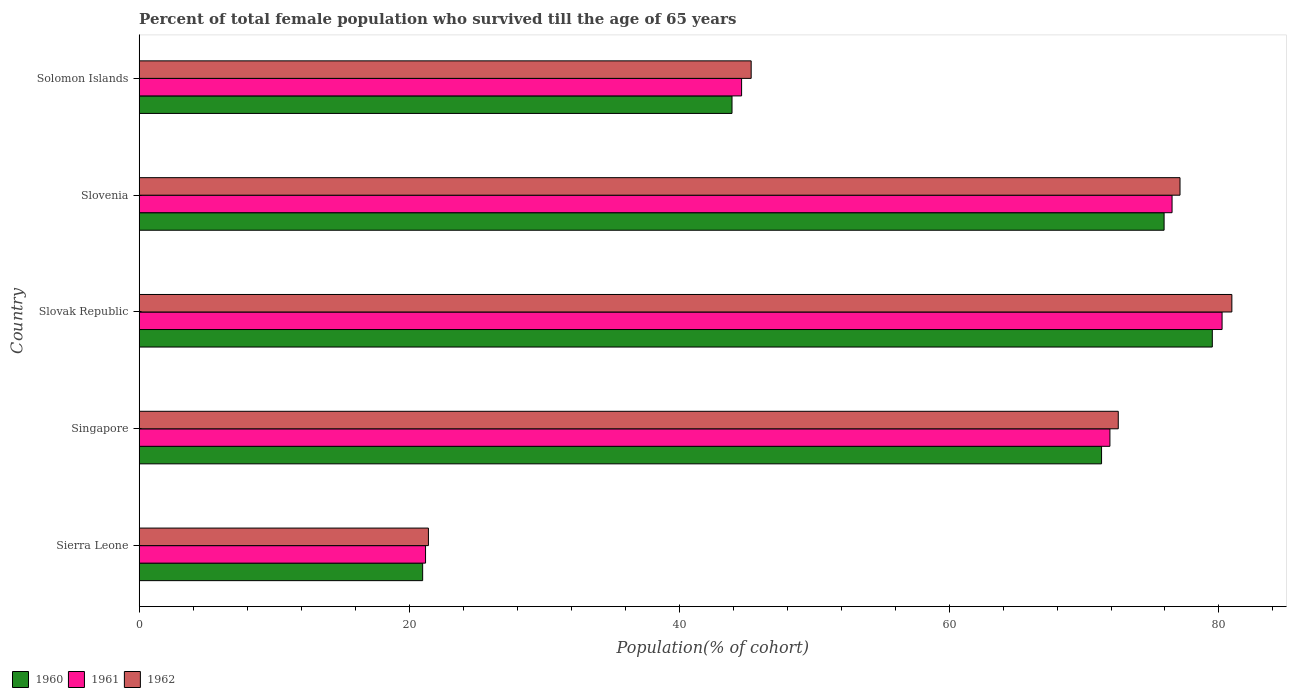How many groups of bars are there?
Your answer should be compact. 5. How many bars are there on the 5th tick from the top?
Offer a terse response. 3. How many bars are there on the 4th tick from the bottom?
Provide a succinct answer. 3. What is the label of the 1st group of bars from the top?
Give a very brief answer. Solomon Islands. In how many cases, is the number of bars for a given country not equal to the number of legend labels?
Your answer should be compact. 0. What is the percentage of total female population who survived till the age of 65 years in 1962 in Slovenia?
Offer a terse response. 77.11. Across all countries, what is the maximum percentage of total female population who survived till the age of 65 years in 1961?
Give a very brief answer. 80.23. Across all countries, what is the minimum percentage of total female population who survived till the age of 65 years in 1960?
Give a very brief answer. 21. In which country was the percentage of total female population who survived till the age of 65 years in 1960 maximum?
Your response must be concise. Slovak Republic. In which country was the percentage of total female population who survived till the age of 65 years in 1961 minimum?
Provide a short and direct response. Sierra Leone. What is the total percentage of total female population who survived till the age of 65 years in 1960 in the graph?
Your answer should be compact. 291.67. What is the difference between the percentage of total female population who survived till the age of 65 years in 1960 in Slovak Republic and that in Solomon Islands?
Your answer should be very brief. 35.58. What is the difference between the percentage of total female population who survived till the age of 65 years in 1962 in Sierra Leone and the percentage of total female population who survived till the age of 65 years in 1961 in Solomon Islands?
Your response must be concise. -23.2. What is the average percentage of total female population who survived till the age of 65 years in 1961 per country?
Your answer should be compact. 58.9. What is the difference between the percentage of total female population who survived till the age of 65 years in 1961 and percentage of total female population who survived till the age of 65 years in 1962 in Solomon Islands?
Your answer should be compact. -0.71. What is the ratio of the percentage of total female population who survived till the age of 65 years in 1960 in Slovak Republic to that in Slovenia?
Give a very brief answer. 1.05. Is the percentage of total female population who survived till the age of 65 years in 1961 in Slovenia less than that in Solomon Islands?
Provide a short and direct response. No. What is the difference between the highest and the second highest percentage of total female population who survived till the age of 65 years in 1960?
Ensure brevity in your answer.  3.57. What is the difference between the highest and the lowest percentage of total female population who survived till the age of 65 years in 1960?
Make the answer very short. 58.5. Is the sum of the percentage of total female population who survived till the age of 65 years in 1960 in Singapore and Slovenia greater than the maximum percentage of total female population who survived till the age of 65 years in 1961 across all countries?
Give a very brief answer. Yes. What does the 1st bar from the top in Sierra Leone represents?
Give a very brief answer. 1962. What does the 2nd bar from the bottom in Slovak Republic represents?
Provide a succinct answer. 1961. Is it the case that in every country, the sum of the percentage of total female population who survived till the age of 65 years in 1962 and percentage of total female population who survived till the age of 65 years in 1960 is greater than the percentage of total female population who survived till the age of 65 years in 1961?
Provide a succinct answer. Yes. How many bars are there?
Provide a short and direct response. 15. How many countries are there in the graph?
Your answer should be compact. 5. What is the difference between two consecutive major ticks on the X-axis?
Your answer should be compact. 20. Where does the legend appear in the graph?
Provide a short and direct response. Bottom left. How are the legend labels stacked?
Provide a short and direct response. Horizontal. What is the title of the graph?
Provide a succinct answer. Percent of total female population who survived till the age of 65 years. What is the label or title of the X-axis?
Keep it short and to the point. Population(% of cohort). What is the Population(% of cohort) of 1960 in Sierra Leone?
Your answer should be very brief. 21. What is the Population(% of cohort) of 1961 in Sierra Leone?
Keep it short and to the point. 21.22. What is the Population(% of cohort) of 1962 in Sierra Leone?
Provide a succinct answer. 21.43. What is the Population(% of cohort) in 1960 in Singapore?
Offer a very short reply. 71.3. What is the Population(% of cohort) of 1961 in Singapore?
Offer a terse response. 71.92. What is the Population(% of cohort) in 1962 in Singapore?
Your answer should be very brief. 72.54. What is the Population(% of cohort) in 1960 in Slovak Republic?
Give a very brief answer. 79.51. What is the Population(% of cohort) of 1961 in Slovak Republic?
Keep it short and to the point. 80.23. What is the Population(% of cohort) of 1962 in Slovak Republic?
Provide a succinct answer. 80.95. What is the Population(% of cohort) in 1960 in Slovenia?
Your answer should be compact. 75.93. What is the Population(% of cohort) of 1961 in Slovenia?
Your answer should be compact. 76.52. What is the Population(% of cohort) of 1962 in Slovenia?
Your answer should be compact. 77.11. What is the Population(% of cohort) of 1960 in Solomon Islands?
Your answer should be very brief. 43.92. What is the Population(% of cohort) in 1961 in Solomon Islands?
Offer a very short reply. 44.63. What is the Population(% of cohort) of 1962 in Solomon Islands?
Provide a short and direct response. 45.34. Across all countries, what is the maximum Population(% of cohort) of 1960?
Ensure brevity in your answer.  79.51. Across all countries, what is the maximum Population(% of cohort) of 1961?
Keep it short and to the point. 80.23. Across all countries, what is the maximum Population(% of cohort) of 1962?
Provide a short and direct response. 80.95. Across all countries, what is the minimum Population(% of cohort) of 1960?
Offer a terse response. 21. Across all countries, what is the minimum Population(% of cohort) of 1961?
Keep it short and to the point. 21.22. Across all countries, what is the minimum Population(% of cohort) of 1962?
Make the answer very short. 21.43. What is the total Population(% of cohort) of 1960 in the graph?
Make the answer very short. 291.67. What is the total Population(% of cohort) in 1961 in the graph?
Offer a very short reply. 294.52. What is the total Population(% of cohort) in 1962 in the graph?
Your answer should be compact. 297.38. What is the difference between the Population(% of cohort) of 1960 in Sierra Leone and that in Singapore?
Offer a very short reply. -50.3. What is the difference between the Population(% of cohort) in 1961 in Sierra Leone and that in Singapore?
Offer a terse response. -50.7. What is the difference between the Population(% of cohort) of 1962 in Sierra Leone and that in Singapore?
Your response must be concise. -51.11. What is the difference between the Population(% of cohort) of 1960 in Sierra Leone and that in Slovak Republic?
Your answer should be very brief. -58.5. What is the difference between the Population(% of cohort) of 1961 in Sierra Leone and that in Slovak Republic?
Provide a short and direct response. -59.01. What is the difference between the Population(% of cohort) of 1962 in Sierra Leone and that in Slovak Republic?
Provide a short and direct response. -59.52. What is the difference between the Population(% of cohort) in 1960 in Sierra Leone and that in Slovenia?
Offer a very short reply. -54.93. What is the difference between the Population(% of cohort) of 1961 in Sierra Leone and that in Slovenia?
Give a very brief answer. -55.31. What is the difference between the Population(% of cohort) of 1962 in Sierra Leone and that in Slovenia?
Ensure brevity in your answer.  -55.68. What is the difference between the Population(% of cohort) of 1960 in Sierra Leone and that in Solomon Islands?
Offer a terse response. -22.92. What is the difference between the Population(% of cohort) of 1961 in Sierra Leone and that in Solomon Islands?
Your response must be concise. -23.42. What is the difference between the Population(% of cohort) of 1962 in Sierra Leone and that in Solomon Islands?
Provide a short and direct response. -23.91. What is the difference between the Population(% of cohort) in 1960 in Singapore and that in Slovak Republic?
Offer a terse response. -8.2. What is the difference between the Population(% of cohort) of 1961 in Singapore and that in Slovak Republic?
Provide a succinct answer. -8.31. What is the difference between the Population(% of cohort) of 1962 in Singapore and that in Slovak Republic?
Offer a terse response. -8.42. What is the difference between the Population(% of cohort) in 1960 in Singapore and that in Slovenia?
Give a very brief answer. -4.63. What is the difference between the Population(% of cohort) in 1961 in Singapore and that in Slovenia?
Ensure brevity in your answer.  -4.6. What is the difference between the Population(% of cohort) of 1962 in Singapore and that in Slovenia?
Keep it short and to the point. -4.57. What is the difference between the Population(% of cohort) in 1960 in Singapore and that in Solomon Islands?
Your response must be concise. 27.38. What is the difference between the Population(% of cohort) in 1961 in Singapore and that in Solomon Islands?
Keep it short and to the point. 27.29. What is the difference between the Population(% of cohort) in 1962 in Singapore and that in Solomon Islands?
Your answer should be compact. 27.2. What is the difference between the Population(% of cohort) in 1960 in Slovak Republic and that in Slovenia?
Make the answer very short. 3.57. What is the difference between the Population(% of cohort) of 1961 in Slovak Republic and that in Slovenia?
Offer a very short reply. 3.71. What is the difference between the Population(% of cohort) in 1962 in Slovak Republic and that in Slovenia?
Your response must be concise. 3.84. What is the difference between the Population(% of cohort) in 1960 in Slovak Republic and that in Solomon Islands?
Ensure brevity in your answer.  35.58. What is the difference between the Population(% of cohort) in 1961 in Slovak Republic and that in Solomon Islands?
Provide a short and direct response. 35.6. What is the difference between the Population(% of cohort) of 1962 in Slovak Republic and that in Solomon Islands?
Your answer should be very brief. 35.61. What is the difference between the Population(% of cohort) in 1960 in Slovenia and that in Solomon Islands?
Your answer should be compact. 32.01. What is the difference between the Population(% of cohort) in 1961 in Slovenia and that in Solomon Islands?
Offer a very short reply. 31.89. What is the difference between the Population(% of cohort) of 1962 in Slovenia and that in Solomon Islands?
Your answer should be very brief. 31.77. What is the difference between the Population(% of cohort) of 1960 in Sierra Leone and the Population(% of cohort) of 1961 in Singapore?
Make the answer very short. -50.92. What is the difference between the Population(% of cohort) of 1960 in Sierra Leone and the Population(% of cohort) of 1962 in Singapore?
Provide a succinct answer. -51.54. What is the difference between the Population(% of cohort) in 1961 in Sierra Leone and the Population(% of cohort) in 1962 in Singapore?
Offer a very short reply. -51.32. What is the difference between the Population(% of cohort) of 1960 in Sierra Leone and the Population(% of cohort) of 1961 in Slovak Republic?
Give a very brief answer. -59.23. What is the difference between the Population(% of cohort) of 1960 in Sierra Leone and the Population(% of cohort) of 1962 in Slovak Republic?
Your answer should be compact. -59.95. What is the difference between the Population(% of cohort) of 1961 in Sierra Leone and the Population(% of cohort) of 1962 in Slovak Republic?
Ensure brevity in your answer.  -59.74. What is the difference between the Population(% of cohort) of 1960 in Sierra Leone and the Population(% of cohort) of 1961 in Slovenia?
Ensure brevity in your answer.  -55.52. What is the difference between the Population(% of cohort) in 1960 in Sierra Leone and the Population(% of cohort) in 1962 in Slovenia?
Your answer should be compact. -56.11. What is the difference between the Population(% of cohort) in 1961 in Sierra Leone and the Population(% of cohort) in 1962 in Slovenia?
Make the answer very short. -55.9. What is the difference between the Population(% of cohort) in 1960 in Sierra Leone and the Population(% of cohort) in 1961 in Solomon Islands?
Give a very brief answer. -23.63. What is the difference between the Population(% of cohort) in 1960 in Sierra Leone and the Population(% of cohort) in 1962 in Solomon Islands?
Provide a succinct answer. -24.34. What is the difference between the Population(% of cohort) of 1961 in Sierra Leone and the Population(% of cohort) of 1962 in Solomon Islands?
Keep it short and to the point. -24.12. What is the difference between the Population(% of cohort) of 1960 in Singapore and the Population(% of cohort) of 1961 in Slovak Republic?
Provide a short and direct response. -8.93. What is the difference between the Population(% of cohort) of 1960 in Singapore and the Population(% of cohort) of 1962 in Slovak Republic?
Your response must be concise. -9.65. What is the difference between the Population(% of cohort) of 1961 in Singapore and the Population(% of cohort) of 1962 in Slovak Republic?
Your answer should be very brief. -9.03. What is the difference between the Population(% of cohort) in 1960 in Singapore and the Population(% of cohort) in 1961 in Slovenia?
Keep it short and to the point. -5.22. What is the difference between the Population(% of cohort) in 1960 in Singapore and the Population(% of cohort) in 1962 in Slovenia?
Ensure brevity in your answer.  -5.81. What is the difference between the Population(% of cohort) in 1961 in Singapore and the Population(% of cohort) in 1962 in Slovenia?
Your answer should be compact. -5.19. What is the difference between the Population(% of cohort) of 1960 in Singapore and the Population(% of cohort) of 1961 in Solomon Islands?
Ensure brevity in your answer.  26.67. What is the difference between the Population(% of cohort) in 1960 in Singapore and the Population(% of cohort) in 1962 in Solomon Islands?
Ensure brevity in your answer.  25.96. What is the difference between the Population(% of cohort) of 1961 in Singapore and the Population(% of cohort) of 1962 in Solomon Islands?
Give a very brief answer. 26.58. What is the difference between the Population(% of cohort) in 1960 in Slovak Republic and the Population(% of cohort) in 1961 in Slovenia?
Offer a very short reply. 2.98. What is the difference between the Population(% of cohort) in 1960 in Slovak Republic and the Population(% of cohort) in 1962 in Slovenia?
Your answer should be compact. 2.39. What is the difference between the Population(% of cohort) of 1961 in Slovak Republic and the Population(% of cohort) of 1962 in Slovenia?
Your answer should be compact. 3.12. What is the difference between the Population(% of cohort) in 1960 in Slovak Republic and the Population(% of cohort) in 1961 in Solomon Islands?
Provide a short and direct response. 34.87. What is the difference between the Population(% of cohort) of 1960 in Slovak Republic and the Population(% of cohort) of 1962 in Solomon Islands?
Give a very brief answer. 34.16. What is the difference between the Population(% of cohort) of 1961 in Slovak Republic and the Population(% of cohort) of 1962 in Solomon Islands?
Offer a very short reply. 34.89. What is the difference between the Population(% of cohort) in 1960 in Slovenia and the Population(% of cohort) in 1961 in Solomon Islands?
Your response must be concise. 31.3. What is the difference between the Population(% of cohort) of 1960 in Slovenia and the Population(% of cohort) of 1962 in Solomon Islands?
Ensure brevity in your answer.  30.59. What is the difference between the Population(% of cohort) of 1961 in Slovenia and the Population(% of cohort) of 1962 in Solomon Islands?
Offer a terse response. 31.18. What is the average Population(% of cohort) in 1960 per country?
Give a very brief answer. 58.33. What is the average Population(% of cohort) of 1961 per country?
Keep it short and to the point. 58.9. What is the average Population(% of cohort) of 1962 per country?
Your answer should be compact. 59.48. What is the difference between the Population(% of cohort) of 1960 and Population(% of cohort) of 1961 in Sierra Leone?
Ensure brevity in your answer.  -0.21. What is the difference between the Population(% of cohort) in 1960 and Population(% of cohort) in 1962 in Sierra Leone?
Your answer should be very brief. -0.43. What is the difference between the Population(% of cohort) in 1961 and Population(% of cohort) in 1962 in Sierra Leone?
Keep it short and to the point. -0.21. What is the difference between the Population(% of cohort) in 1960 and Population(% of cohort) in 1961 in Singapore?
Offer a terse response. -0.62. What is the difference between the Population(% of cohort) of 1960 and Population(% of cohort) of 1962 in Singapore?
Provide a short and direct response. -1.24. What is the difference between the Population(% of cohort) in 1961 and Population(% of cohort) in 1962 in Singapore?
Offer a very short reply. -0.62. What is the difference between the Population(% of cohort) of 1960 and Population(% of cohort) of 1961 in Slovak Republic?
Provide a short and direct response. -0.72. What is the difference between the Population(% of cohort) of 1960 and Population(% of cohort) of 1962 in Slovak Republic?
Your response must be concise. -1.45. What is the difference between the Population(% of cohort) in 1961 and Population(% of cohort) in 1962 in Slovak Republic?
Your answer should be very brief. -0.72. What is the difference between the Population(% of cohort) of 1960 and Population(% of cohort) of 1961 in Slovenia?
Provide a succinct answer. -0.59. What is the difference between the Population(% of cohort) of 1960 and Population(% of cohort) of 1962 in Slovenia?
Offer a terse response. -1.18. What is the difference between the Population(% of cohort) of 1961 and Population(% of cohort) of 1962 in Slovenia?
Ensure brevity in your answer.  -0.59. What is the difference between the Population(% of cohort) of 1960 and Population(% of cohort) of 1961 in Solomon Islands?
Your answer should be compact. -0.71. What is the difference between the Population(% of cohort) in 1960 and Population(% of cohort) in 1962 in Solomon Islands?
Make the answer very short. -1.42. What is the difference between the Population(% of cohort) of 1961 and Population(% of cohort) of 1962 in Solomon Islands?
Offer a very short reply. -0.71. What is the ratio of the Population(% of cohort) of 1960 in Sierra Leone to that in Singapore?
Keep it short and to the point. 0.29. What is the ratio of the Population(% of cohort) in 1961 in Sierra Leone to that in Singapore?
Offer a very short reply. 0.29. What is the ratio of the Population(% of cohort) of 1962 in Sierra Leone to that in Singapore?
Ensure brevity in your answer.  0.3. What is the ratio of the Population(% of cohort) in 1960 in Sierra Leone to that in Slovak Republic?
Your response must be concise. 0.26. What is the ratio of the Population(% of cohort) in 1961 in Sierra Leone to that in Slovak Republic?
Your response must be concise. 0.26. What is the ratio of the Population(% of cohort) of 1962 in Sierra Leone to that in Slovak Republic?
Your answer should be very brief. 0.26. What is the ratio of the Population(% of cohort) of 1960 in Sierra Leone to that in Slovenia?
Your response must be concise. 0.28. What is the ratio of the Population(% of cohort) of 1961 in Sierra Leone to that in Slovenia?
Provide a succinct answer. 0.28. What is the ratio of the Population(% of cohort) of 1962 in Sierra Leone to that in Slovenia?
Ensure brevity in your answer.  0.28. What is the ratio of the Population(% of cohort) of 1960 in Sierra Leone to that in Solomon Islands?
Your response must be concise. 0.48. What is the ratio of the Population(% of cohort) of 1961 in Sierra Leone to that in Solomon Islands?
Your answer should be very brief. 0.48. What is the ratio of the Population(% of cohort) of 1962 in Sierra Leone to that in Solomon Islands?
Provide a short and direct response. 0.47. What is the ratio of the Population(% of cohort) of 1960 in Singapore to that in Slovak Republic?
Provide a succinct answer. 0.9. What is the ratio of the Population(% of cohort) in 1961 in Singapore to that in Slovak Republic?
Offer a terse response. 0.9. What is the ratio of the Population(% of cohort) of 1962 in Singapore to that in Slovak Republic?
Offer a very short reply. 0.9. What is the ratio of the Population(% of cohort) in 1960 in Singapore to that in Slovenia?
Give a very brief answer. 0.94. What is the ratio of the Population(% of cohort) in 1961 in Singapore to that in Slovenia?
Make the answer very short. 0.94. What is the ratio of the Population(% of cohort) in 1962 in Singapore to that in Slovenia?
Make the answer very short. 0.94. What is the ratio of the Population(% of cohort) of 1960 in Singapore to that in Solomon Islands?
Your answer should be compact. 1.62. What is the ratio of the Population(% of cohort) of 1961 in Singapore to that in Solomon Islands?
Your answer should be compact. 1.61. What is the ratio of the Population(% of cohort) in 1962 in Singapore to that in Solomon Islands?
Offer a terse response. 1.6. What is the ratio of the Population(% of cohort) of 1960 in Slovak Republic to that in Slovenia?
Your response must be concise. 1.05. What is the ratio of the Population(% of cohort) of 1961 in Slovak Republic to that in Slovenia?
Ensure brevity in your answer.  1.05. What is the ratio of the Population(% of cohort) in 1962 in Slovak Republic to that in Slovenia?
Your response must be concise. 1.05. What is the ratio of the Population(% of cohort) in 1960 in Slovak Republic to that in Solomon Islands?
Offer a terse response. 1.81. What is the ratio of the Population(% of cohort) in 1961 in Slovak Republic to that in Solomon Islands?
Keep it short and to the point. 1.8. What is the ratio of the Population(% of cohort) in 1962 in Slovak Republic to that in Solomon Islands?
Provide a succinct answer. 1.79. What is the ratio of the Population(% of cohort) of 1960 in Slovenia to that in Solomon Islands?
Your answer should be compact. 1.73. What is the ratio of the Population(% of cohort) in 1961 in Slovenia to that in Solomon Islands?
Ensure brevity in your answer.  1.71. What is the ratio of the Population(% of cohort) of 1962 in Slovenia to that in Solomon Islands?
Ensure brevity in your answer.  1.7. What is the difference between the highest and the second highest Population(% of cohort) of 1960?
Ensure brevity in your answer.  3.57. What is the difference between the highest and the second highest Population(% of cohort) in 1961?
Provide a succinct answer. 3.71. What is the difference between the highest and the second highest Population(% of cohort) in 1962?
Provide a short and direct response. 3.84. What is the difference between the highest and the lowest Population(% of cohort) of 1960?
Keep it short and to the point. 58.5. What is the difference between the highest and the lowest Population(% of cohort) in 1961?
Your answer should be very brief. 59.01. What is the difference between the highest and the lowest Population(% of cohort) of 1962?
Provide a short and direct response. 59.52. 